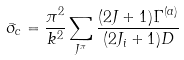Convert formula to latex. <formula><loc_0><loc_0><loc_500><loc_500>\bar { \sigma } _ { c } = \frac { \pi ^ { 2 } } { k ^ { 2 } } \sum _ { J ^ { \pi } } \frac { ( 2 J + 1 ) \Gamma ^ { ( a ) } } { ( 2 J _ { i } + 1 ) D }</formula> 